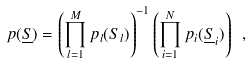<formula> <loc_0><loc_0><loc_500><loc_500>p ( \underline { S } ) = \left ( \prod _ { l = 1 } ^ { M } p _ { l } ( S _ { l } ) \right ) ^ { - 1 } \left ( \prod _ { i = 1 } ^ { N } p _ { i } ( \underline { S } _ { i } ) \right ) \ ,</formula> 